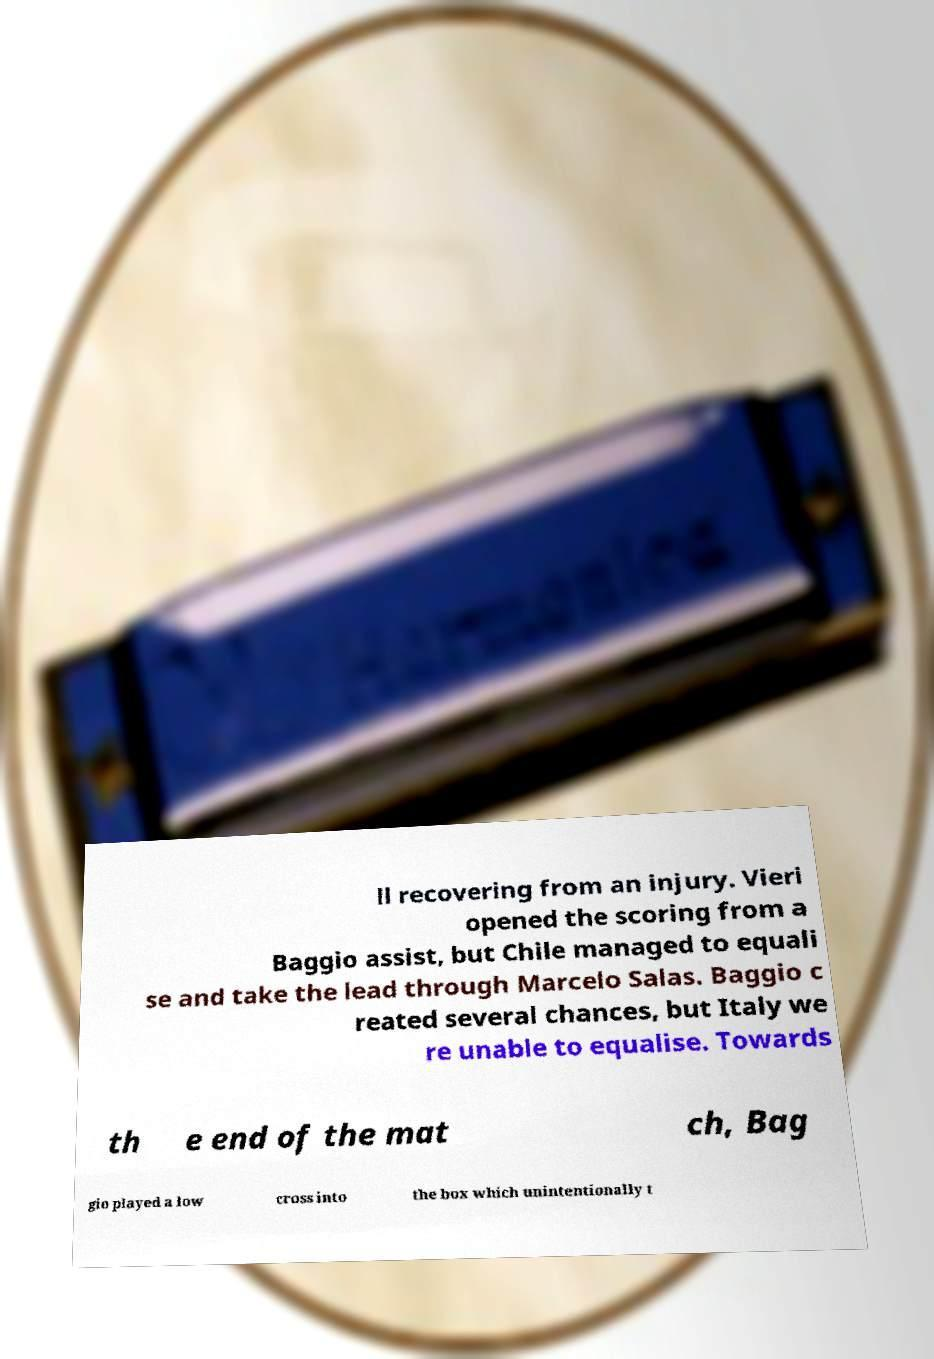Could you extract and type out the text from this image? ll recovering from an injury. Vieri opened the scoring from a Baggio assist, but Chile managed to equali se and take the lead through Marcelo Salas. Baggio c reated several chances, but Italy we re unable to equalise. Towards th e end of the mat ch, Bag gio played a low cross into the box which unintentionally t 